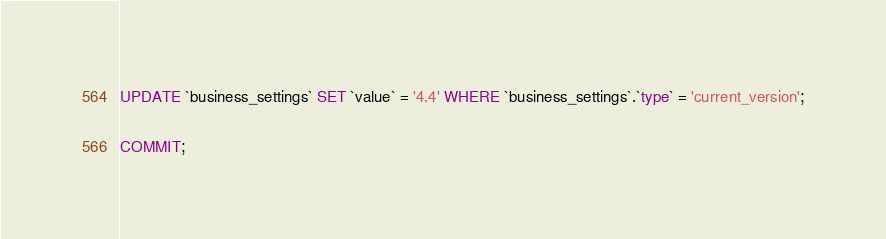<code> <loc_0><loc_0><loc_500><loc_500><_SQL_>UPDATE `business_settings` SET `value` = '4.4' WHERE `business_settings`.`type` = 'current_version';

COMMIT;
</code> 